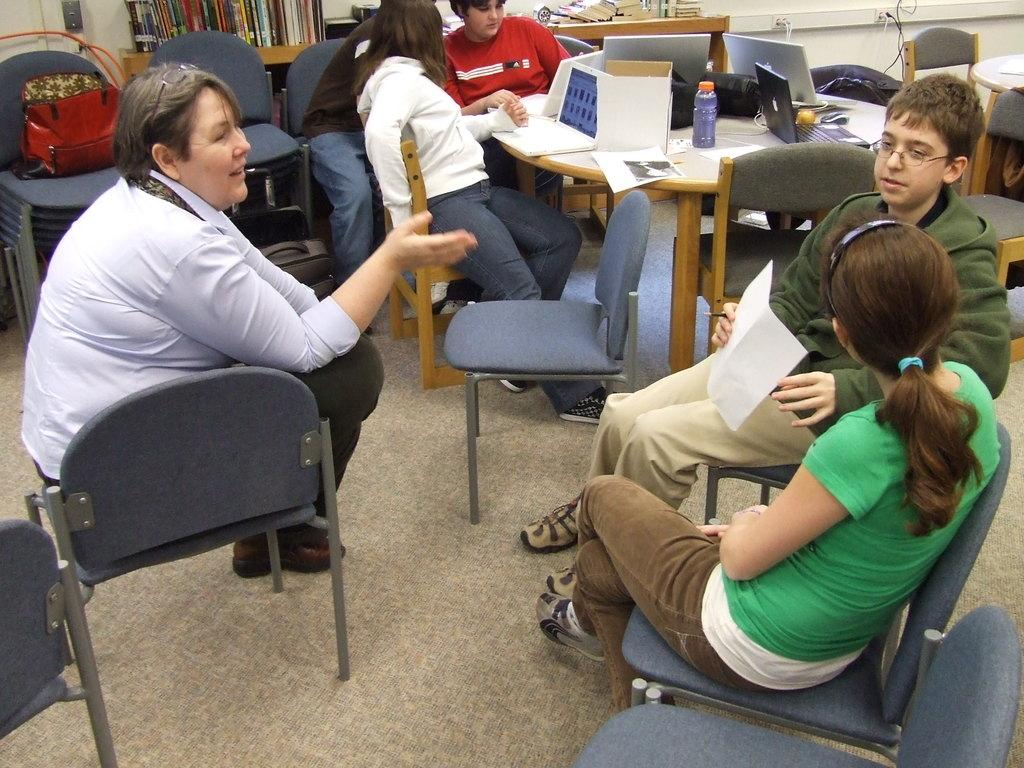How many people are in the image? There is a group of persons in the image. What are the persons doing in the image? The persons are sitting on chairs and discussing something. What objects are on the table in the image? There are laptops and water bottles on the table. Where is the tray located in the image? There is no tray present in the image. What type of books are the persons reading in the image? There are no books present in the image; the persons are discussing something. 